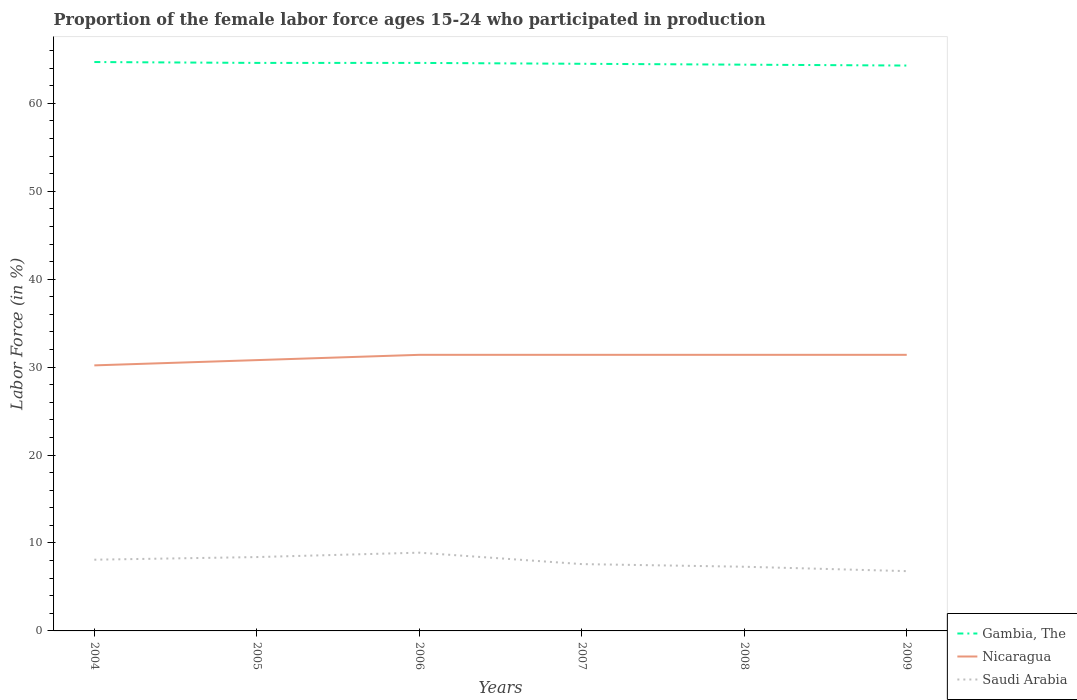How many different coloured lines are there?
Keep it short and to the point. 3. Is the number of lines equal to the number of legend labels?
Give a very brief answer. Yes. Across all years, what is the maximum proportion of the female labor force who participated in production in Nicaragua?
Provide a short and direct response. 30.2. What is the total proportion of the female labor force who participated in production in Nicaragua in the graph?
Offer a very short reply. -0.6. What is the difference between the highest and the second highest proportion of the female labor force who participated in production in Nicaragua?
Your response must be concise. 1.2. Is the proportion of the female labor force who participated in production in Saudi Arabia strictly greater than the proportion of the female labor force who participated in production in Nicaragua over the years?
Ensure brevity in your answer.  Yes. How many lines are there?
Offer a terse response. 3. What is the difference between two consecutive major ticks on the Y-axis?
Ensure brevity in your answer.  10. Does the graph contain any zero values?
Your answer should be very brief. No. Does the graph contain grids?
Your response must be concise. No. Where does the legend appear in the graph?
Your response must be concise. Bottom right. How are the legend labels stacked?
Your response must be concise. Vertical. What is the title of the graph?
Give a very brief answer. Proportion of the female labor force ages 15-24 who participated in production. Does "Micronesia" appear as one of the legend labels in the graph?
Give a very brief answer. No. What is the Labor Force (in %) of Gambia, The in 2004?
Ensure brevity in your answer.  64.7. What is the Labor Force (in %) of Nicaragua in 2004?
Offer a terse response. 30.2. What is the Labor Force (in %) of Saudi Arabia in 2004?
Provide a succinct answer. 8.1. What is the Labor Force (in %) of Gambia, The in 2005?
Provide a succinct answer. 64.6. What is the Labor Force (in %) in Nicaragua in 2005?
Offer a terse response. 30.8. What is the Labor Force (in %) in Saudi Arabia in 2005?
Provide a succinct answer. 8.4. What is the Labor Force (in %) of Gambia, The in 2006?
Keep it short and to the point. 64.6. What is the Labor Force (in %) in Nicaragua in 2006?
Your answer should be compact. 31.4. What is the Labor Force (in %) in Saudi Arabia in 2006?
Your answer should be compact. 8.9. What is the Labor Force (in %) of Gambia, The in 2007?
Give a very brief answer. 64.5. What is the Labor Force (in %) in Nicaragua in 2007?
Keep it short and to the point. 31.4. What is the Labor Force (in %) of Saudi Arabia in 2007?
Ensure brevity in your answer.  7.6. What is the Labor Force (in %) in Gambia, The in 2008?
Your answer should be compact. 64.4. What is the Labor Force (in %) in Nicaragua in 2008?
Offer a very short reply. 31.4. What is the Labor Force (in %) of Saudi Arabia in 2008?
Give a very brief answer. 7.3. What is the Labor Force (in %) of Gambia, The in 2009?
Make the answer very short. 64.3. What is the Labor Force (in %) in Nicaragua in 2009?
Offer a terse response. 31.4. What is the Labor Force (in %) of Saudi Arabia in 2009?
Give a very brief answer. 6.8. Across all years, what is the maximum Labor Force (in %) in Gambia, The?
Provide a short and direct response. 64.7. Across all years, what is the maximum Labor Force (in %) of Nicaragua?
Your answer should be very brief. 31.4. Across all years, what is the maximum Labor Force (in %) of Saudi Arabia?
Provide a short and direct response. 8.9. Across all years, what is the minimum Labor Force (in %) in Gambia, The?
Your answer should be very brief. 64.3. Across all years, what is the minimum Labor Force (in %) in Nicaragua?
Your response must be concise. 30.2. Across all years, what is the minimum Labor Force (in %) in Saudi Arabia?
Keep it short and to the point. 6.8. What is the total Labor Force (in %) of Gambia, The in the graph?
Your response must be concise. 387.1. What is the total Labor Force (in %) in Nicaragua in the graph?
Ensure brevity in your answer.  186.6. What is the total Labor Force (in %) of Saudi Arabia in the graph?
Provide a short and direct response. 47.1. What is the difference between the Labor Force (in %) in Gambia, The in 2004 and that in 2005?
Your answer should be compact. 0.1. What is the difference between the Labor Force (in %) in Saudi Arabia in 2004 and that in 2005?
Give a very brief answer. -0.3. What is the difference between the Labor Force (in %) in Nicaragua in 2004 and that in 2006?
Offer a terse response. -1.2. What is the difference between the Labor Force (in %) of Gambia, The in 2004 and that in 2007?
Give a very brief answer. 0.2. What is the difference between the Labor Force (in %) in Nicaragua in 2004 and that in 2007?
Your answer should be very brief. -1.2. What is the difference between the Labor Force (in %) of Saudi Arabia in 2004 and that in 2007?
Provide a short and direct response. 0.5. What is the difference between the Labor Force (in %) of Gambia, The in 2004 and that in 2008?
Ensure brevity in your answer.  0.3. What is the difference between the Labor Force (in %) of Saudi Arabia in 2004 and that in 2009?
Ensure brevity in your answer.  1.3. What is the difference between the Labor Force (in %) of Gambia, The in 2005 and that in 2006?
Give a very brief answer. 0. What is the difference between the Labor Force (in %) of Nicaragua in 2005 and that in 2006?
Make the answer very short. -0.6. What is the difference between the Labor Force (in %) in Saudi Arabia in 2005 and that in 2006?
Offer a terse response. -0.5. What is the difference between the Labor Force (in %) of Gambia, The in 2005 and that in 2007?
Offer a very short reply. 0.1. What is the difference between the Labor Force (in %) in Nicaragua in 2005 and that in 2009?
Provide a short and direct response. -0.6. What is the difference between the Labor Force (in %) of Gambia, The in 2006 and that in 2007?
Your response must be concise. 0.1. What is the difference between the Labor Force (in %) of Nicaragua in 2006 and that in 2007?
Your answer should be compact. 0. What is the difference between the Labor Force (in %) in Nicaragua in 2006 and that in 2009?
Ensure brevity in your answer.  0. What is the difference between the Labor Force (in %) of Saudi Arabia in 2006 and that in 2009?
Give a very brief answer. 2.1. What is the difference between the Labor Force (in %) of Nicaragua in 2007 and that in 2008?
Make the answer very short. 0. What is the difference between the Labor Force (in %) of Saudi Arabia in 2007 and that in 2008?
Offer a terse response. 0.3. What is the difference between the Labor Force (in %) of Gambia, The in 2007 and that in 2009?
Ensure brevity in your answer.  0.2. What is the difference between the Labor Force (in %) of Nicaragua in 2007 and that in 2009?
Make the answer very short. 0. What is the difference between the Labor Force (in %) of Nicaragua in 2008 and that in 2009?
Provide a short and direct response. 0. What is the difference between the Labor Force (in %) in Gambia, The in 2004 and the Labor Force (in %) in Nicaragua in 2005?
Keep it short and to the point. 33.9. What is the difference between the Labor Force (in %) of Gambia, The in 2004 and the Labor Force (in %) of Saudi Arabia in 2005?
Offer a very short reply. 56.3. What is the difference between the Labor Force (in %) of Nicaragua in 2004 and the Labor Force (in %) of Saudi Arabia in 2005?
Ensure brevity in your answer.  21.8. What is the difference between the Labor Force (in %) in Gambia, The in 2004 and the Labor Force (in %) in Nicaragua in 2006?
Your answer should be compact. 33.3. What is the difference between the Labor Force (in %) of Gambia, The in 2004 and the Labor Force (in %) of Saudi Arabia in 2006?
Your response must be concise. 55.8. What is the difference between the Labor Force (in %) in Nicaragua in 2004 and the Labor Force (in %) in Saudi Arabia in 2006?
Your answer should be compact. 21.3. What is the difference between the Labor Force (in %) in Gambia, The in 2004 and the Labor Force (in %) in Nicaragua in 2007?
Offer a very short reply. 33.3. What is the difference between the Labor Force (in %) in Gambia, The in 2004 and the Labor Force (in %) in Saudi Arabia in 2007?
Offer a very short reply. 57.1. What is the difference between the Labor Force (in %) of Nicaragua in 2004 and the Labor Force (in %) of Saudi Arabia in 2007?
Offer a terse response. 22.6. What is the difference between the Labor Force (in %) of Gambia, The in 2004 and the Labor Force (in %) of Nicaragua in 2008?
Your answer should be very brief. 33.3. What is the difference between the Labor Force (in %) in Gambia, The in 2004 and the Labor Force (in %) in Saudi Arabia in 2008?
Provide a short and direct response. 57.4. What is the difference between the Labor Force (in %) of Nicaragua in 2004 and the Labor Force (in %) of Saudi Arabia in 2008?
Your response must be concise. 22.9. What is the difference between the Labor Force (in %) of Gambia, The in 2004 and the Labor Force (in %) of Nicaragua in 2009?
Give a very brief answer. 33.3. What is the difference between the Labor Force (in %) of Gambia, The in 2004 and the Labor Force (in %) of Saudi Arabia in 2009?
Offer a very short reply. 57.9. What is the difference between the Labor Force (in %) of Nicaragua in 2004 and the Labor Force (in %) of Saudi Arabia in 2009?
Ensure brevity in your answer.  23.4. What is the difference between the Labor Force (in %) of Gambia, The in 2005 and the Labor Force (in %) of Nicaragua in 2006?
Your answer should be very brief. 33.2. What is the difference between the Labor Force (in %) of Gambia, The in 2005 and the Labor Force (in %) of Saudi Arabia in 2006?
Your answer should be very brief. 55.7. What is the difference between the Labor Force (in %) in Nicaragua in 2005 and the Labor Force (in %) in Saudi Arabia in 2006?
Provide a short and direct response. 21.9. What is the difference between the Labor Force (in %) in Gambia, The in 2005 and the Labor Force (in %) in Nicaragua in 2007?
Your response must be concise. 33.2. What is the difference between the Labor Force (in %) in Gambia, The in 2005 and the Labor Force (in %) in Saudi Arabia in 2007?
Give a very brief answer. 57. What is the difference between the Labor Force (in %) in Nicaragua in 2005 and the Labor Force (in %) in Saudi Arabia in 2007?
Offer a terse response. 23.2. What is the difference between the Labor Force (in %) in Gambia, The in 2005 and the Labor Force (in %) in Nicaragua in 2008?
Provide a succinct answer. 33.2. What is the difference between the Labor Force (in %) of Gambia, The in 2005 and the Labor Force (in %) of Saudi Arabia in 2008?
Your response must be concise. 57.3. What is the difference between the Labor Force (in %) of Gambia, The in 2005 and the Labor Force (in %) of Nicaragua in 2009?
Make the answer very short. 33.2. What is the difference between the Labor Force (in %) of Gambia, The in 2005 and the Labor Force (in %) of Saudi Arabia in 2009?
Provide a short and direct response. 57.8. What is the difference between the Labor Force (in %) in Nicaragua in 2005 and the Labor Force (in %) in Saudi Arabia in 2009?
Provide a succinct answer. 24. What is the difference between the Labor Force (in %) in Gambia, The in 2006 and the Labor Force (in %) in Nicaragua in 2007?
Your answer should be compact. 33.2. What is the difference between the Labor Force (in %) of Gambia, The in 2006 and the Labor Force (in %) of Saudi Arabia in 2007?
Offer a terse response. 57. What is the difference between the Labor Force (in %) of Nicaragua in 2006 and the Labor Force (in %) of Saudi Arabia in 2007?
Provide a short and direct response. 23.8. What is the difference between the Labor Force (in %) in Gambia, The in 2006 and the Labor Force (in %) in Nicaragua in 2008?
Ensure brevity in your answer.  33.2. What is the difference between the Labor Force (in %) of Gambia, The in 2006 and the Labor Force (in %) of Saudi Arabia in 2008?
Your answer should be compact. 57.3. What is the difference between the Labor Force (in %) of Nicaragua in 2006 and the Labor Force (in %) of Saudi Arabia in 2008?
Ensure brevity in your answer.  24.1. What is the difference between the Labor Force (in %) in Gambia, The in 2006 and the Labor Force (in %) in Nicaragua in 2009?
Ensure brevity in your answer.  33.2. What is the difference between the Labor Force (in %) of Gambia, The in 2006 and the Labor Force (in %) of Saudi Arabia in 2009?
Your answer should be compact. 57.8. What is the difference between the Labor Force (in %) of Nicaragua in 2006 and the Labor Force (in %) of Saudi Arabia in 2009?
Offer a very short reply. 24.6. What is the difference between the Labor Force (in %) in Gambia, The in 2007 and the Labor Force (in %) in Nicaragua in 2008?
Offer a very short reply. 33.1. What is the difference between the Labor Force (in %) in Gambia, The in 2007 and the Labor Force (in %) in Saudi Arabia in 2008?
Ensure brevity in your answer.  57.2. What is the difference between the Labor Force (in %) of Nicaragua in 2007 and the Labor Force (in %) of Saudi Arabia in 2008?
Provide a succinct answer. 24.1. What is the difference between the Labor Force (in %) in Gambia, The in 2007 and the Labor Force (in %) in Nicaragua in 2009?
Your response must be concise. 33.1. What is the difference between the Labor Force (in %) in Gambia, The in 2007 and the Labor Force (in %) in Saudi Arabia in 2009?
Give a very brief answer. 57.7. What is the difference between the Labor Force (in %) of Nicaragua in 2007 and the Labor Force (in %) of Saudi Arabia in 2009?
Your answer should be compact. 24.6. What is the difference between the Labor Force (in %) of Gambia, The in 2008 and the Labor Force (in %) of Saudi Arabia in 2009?
Provide a short and direct response. 57.6. What is the difference between the Labor Force (in %) of Nicaragua in 2008 and the Labor Force (in %) of Saudi Arabia in 2009?
Your response must be concise. 24.6. What is the average Labor Force (in %) in Gambia, The per year?
Your answer should be compact. 64.52. What is the average Labor Force (in %) in Nicaragua per year?
Provide a succinct answer. 31.1. What is the average Labor Force (in %) in Saudi Arabia per year?
Your response must be concise. 7.85. In the year 2004, what is the difference between the Labor Force (in %) of Gambia, The and Labor Force (in %) of Nicaragua?
Your response must be concise. 34.5. In the year 2004, what is the difference between the Labor Force (in %) in Gambia, The and Labor Force (in %) in Saudi Arabia?
Give a very brief answer. 56.6. In the year 2004, what is the difference between the Labor Force (in %) of Nicaragua and Labor Force (in %) of Saudi Arabia?
Provide a short and direct response. 22.1. In the year 2005, what is the difference between the Labor Force (in %) of Gambia, The and Labor Force (in %) of Nicaragua?
Keep it short and to the point. 33.8. In the year 2005, what is the difference between the Labor Force (in %) of Gambia, The and Labor Force (in %) of Saudi Arabia?
Offer a terse response. 56.2. In the year 2005, what is the difference between the Labor Force (in %) of Nicaragua and Labor Force (in %) of Saudi Arabia?
Give a very brief answer. 22.4. In the year 2006, what is the difference between the Labor Force (in %) in Gambia, The and Labor Force (in %) in Nicaragua?
Offer a terse response. 33.2. In the year 2006, what is the difference between the Labor Force (in %) of Gambia, The and Labor Force (in %) of Saudi Arabia?
Ensure brevity in your answer.  55.7. In the year 2007, what is the difference between the Labor Force (in %) of Gambia, The and Labor Force (in %) of Nicaragua?
Provide a short and direct response. 33.1. In the year 2007, what is the difference between the Labor Force (in %) of Gambia, The and Labor Force (in %) of Saudi Arabia?
Ensure brevity in your answer.  56.9. In the year 2007, what is the difference between the Labor Force (in %) in Nicaragua and Labor Force (in %) in Saudi Arabia?
Your answer should be very brief. 23.8. In the year 2008, what is the difference between the Labor Force (in %) of Gambia, The and Labor Force (in %) of Nicaragua?
Give a very brief answer. 33. In the year 2008, what is the difference between the Labor Force (in %) in Gambia, The and Labor Force (in %) in Saudi Arabia?
Give a very brief answer. 57.1. In the year 2008, what is the difference between the Labor Force (in %) of Nicaragua and Labor Force (in %) of Saudi Arabia?
Provide a succinct answer. 24.1. In the year 2009, what is the difference between the Labor Force (in %) in Gambia, The and Labor Force (in %) in Nicaragua?
Provide a short and direct response. 32.9. In the year 2009, what is the difference between the Labor Force (in %) in Gambia, The and Labor Force (in %) in Saudi Arabia?
Provide a succinct answer. 57.5. In the year 2009, what is the difference between the Labor Force (in %) of Nicaragua and Labor Force (in %) of Saudi Arabia?
Provide a short and direct response. 24.6. What is the ratio of the Labor Force (in %) of Nicaragua in 2004 to that in 2005?
Your answer should be compact. 0.98. What is the ratio of the Labor Force (in %) of Saudi Arabia in 2004 to that in 2005?
Keep it short and to the point. 0.96. What is the ratio of the Labor Force (in %) in Nicaragua in 2004 to that in 2006?
Offer a very short reply. 0.96. What is the ratio of the Labor Force (in %) of Saudi Arabia in 2004 to that in 2006?
Ensure brevity in your answer.  0.91. What is the ratio of the Labor Force (in %) in Gambia, The in 2004 to that in 2007?
Provide a succinct answer. 1. What is the ratio of the Labor Force (in %) of Nicaragua in 2004 to that in 2007?
Provide a short and direct response. 0.96. What is the ratio of the Labor Force (in %) in Saudi Arabia in 2004 to that in 2007?
Ensure brevity in your answer.  1.07. What is the ratio of the Labor Force (in %) of Gambia, The in 2004 to that in 2008?
Give a very brief answer. 1. What is the ratio of the Labor Force (in %) in Nicaragua in 2004 to that in 2008?
Provide a succinct answer. 0.96. What is the ratio of the Labor Force (in %) in Saudi Arabia in 2004 to that in 2008?
Ensure brevity in your answer.  1.11. What is the ratio of the Labor Force (in %) in Nicaragua in 2004 to that in 2009?
Give a very brief answer. 0.96. What is the ratio of the Labor Force (in %) of Saudi Arabia in 2004 to that in 2009?
Offer a terse response. 1.19. What is the ratio of the Labor Force (in %) in Nicaragua in 2005 to that in 2006?
Make the answer very short. 0.98. What is the ratio of the Labor Force (in %) of Saudi Arabia in 2005 to that in 2006?
Make the answer very short. 0.94. What is the ratio of the Labor Force (in %) in Nicaragua in 2005 to that in 2007?
Keep it short and to the point. 0.98. What is the ratio of the Labor Force (in %) of Saudi Arabia in 2005 to that in 2007?
Your response must be concise. 1.11. What is the ratio of the Labor Force (in %) of Nicaragua in 2005 to that in 2008?
Your response must be concise. 0.98. What is the ratio of the Labor Force (in %) of Saudi Arabia in 2005 to that in 2008?
Provide a succinct answer. 1.15. What is the ratio of the Labor Force (in %) of Nicaragua in 2005 to that in 2009?
Offer a very short reply. 0.98. What is the ratio of the Labor Force (in %) of Saudi Arabia in 2005 to that in 2009?
Offer a very short reply. 1.24. What is the ratio of the Labor Force (in %) in Saudi Arabia in 2006 to that in 2007?
Give a very brief answer. 1.17. What is the ratio of the Labor Force (in %) in Nicaragua in 2006 to that in 2008?
Keep it short and to the point. 1. What is the ratio of the Labor Force (in %) in Saudi Arabia in 2006 to that in 2008?
Your answer should be very brief. 1.22. What is the ratio of the Labor Force (in %) in Saudi Arabia in 2006 to that in 2009?
Make the answer very short. 1.31. What is the ratio of the Labor Force (in %) of Gambia, The in 2007 to that in 2008?
Give a very brief answer. 1. What is the ratio of the Labor Force (in %) in Nicaragua in 2007 to that in 2008?
Your answer should be compact. 1. What is the ratio of the Labor Force (in %) of Saudi Arabia in 2007 to that in 2008?
Offer a terse response. 1.04. What is the ratio of the Labor Force (in %) of Saudi Arabia in 2007 to that in 2009?
Your answer should be very brief. 1.12. What is the ratio of the Labor Force (in %) in Gambia, The in 2008 to that in 2009?
Ensure brevity in your answer.  1. What is the ratio of the Labor Force (in %) in Saudi Arabia in 2008 to that in 2009?
Provide a short and direct response. 1.07. What is the difference between the highest and the lowest Labor Force (in %) in Nicaragua?
Keep it short and to the point. 1.2. 